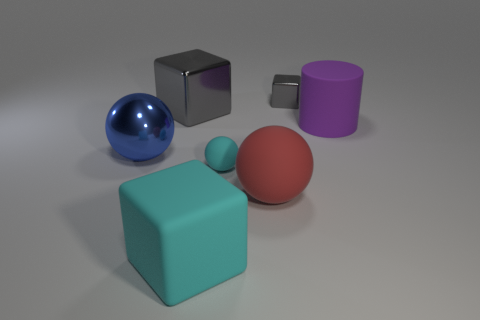What is the color of the block that is in front of the cyan rubber thing that is behind the big cyan thing?
Ensure brevity in your answer.  Cyan. Do the rubber block and the big cube that is behind the big cyan cube have the same color?
Ensure brevity in your answer.  No. There is a thing that is in front of the large gray cube and on the right side of the red object; what material is it?
Ensure brevity in your answer.  Rubber. Are there any purple matte things of the same size as the red rubber ball?
Offer a terse response. Yes. There is a cylinder that is the same size as the blue object; what material is it?
Keep it short and to the point. Rubber. What number of large matte things are behind the red object?
Make the answer very short. 1. There is a cyan matte thing that is behind the large red matte sphere; does it have the same shape as the large gray metallic thing?
Give a very brief answer. No. Is there a gray thing that has the same shape as the red thing?
Offer a terse response. No. There is a sphere that is the same color as the matte cube; what is its material?
Make the answer very short. Rubber. There is a cyan object in front of the small object in front of the large cylinder; what is its shape?
Your response must be concise. Cube. 